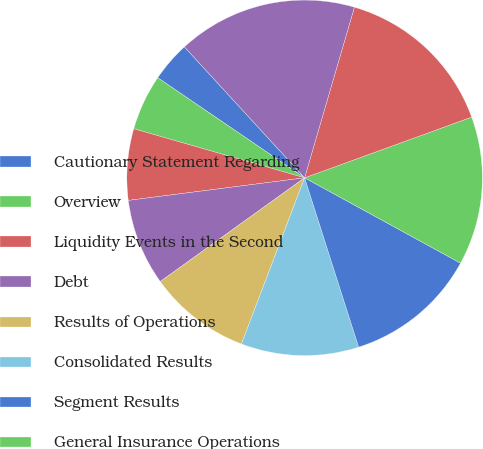Convert chart to OTSL. <chart><loc_0><loc_0><loc_500><loc_500><pie_chart><fcel>Cautionary Statement Regarding<fcel>Overview<fcel>Liquidity Events in the Second<fcel>Debt<fcel>Results of Operations<fcel>Consolidated Results<fcel>Segment Results<fcel>General Insurance Operations<fcel>Liability for unpaid claims<fcel>Life Insurance & Retirement<nl><fcel>3.66%<fcel>5.07%<fcel>6.48%<fcel>7.89%<fcel>9.3%<fcel>10.7%<fcel>12.11%<fcel>13.52%<fcel>14.93%<fcel>16.34%<nl></chart> 